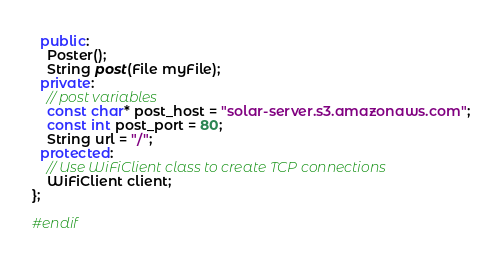Convert code to text. <code><loc_0><loc_0><loc_500><loc_500><_C++_>  public:
    Poster();
    String post(File myFile);
  private:
    // post variables
    const char* post_host = "solar-server.s3.amazonaws.com";
    const int post_port = 80;
    String url = "/";
  protected:
    // Use WiFiClient class to create TCP connections
    WiFiClient client;
};

#endif
</code> 